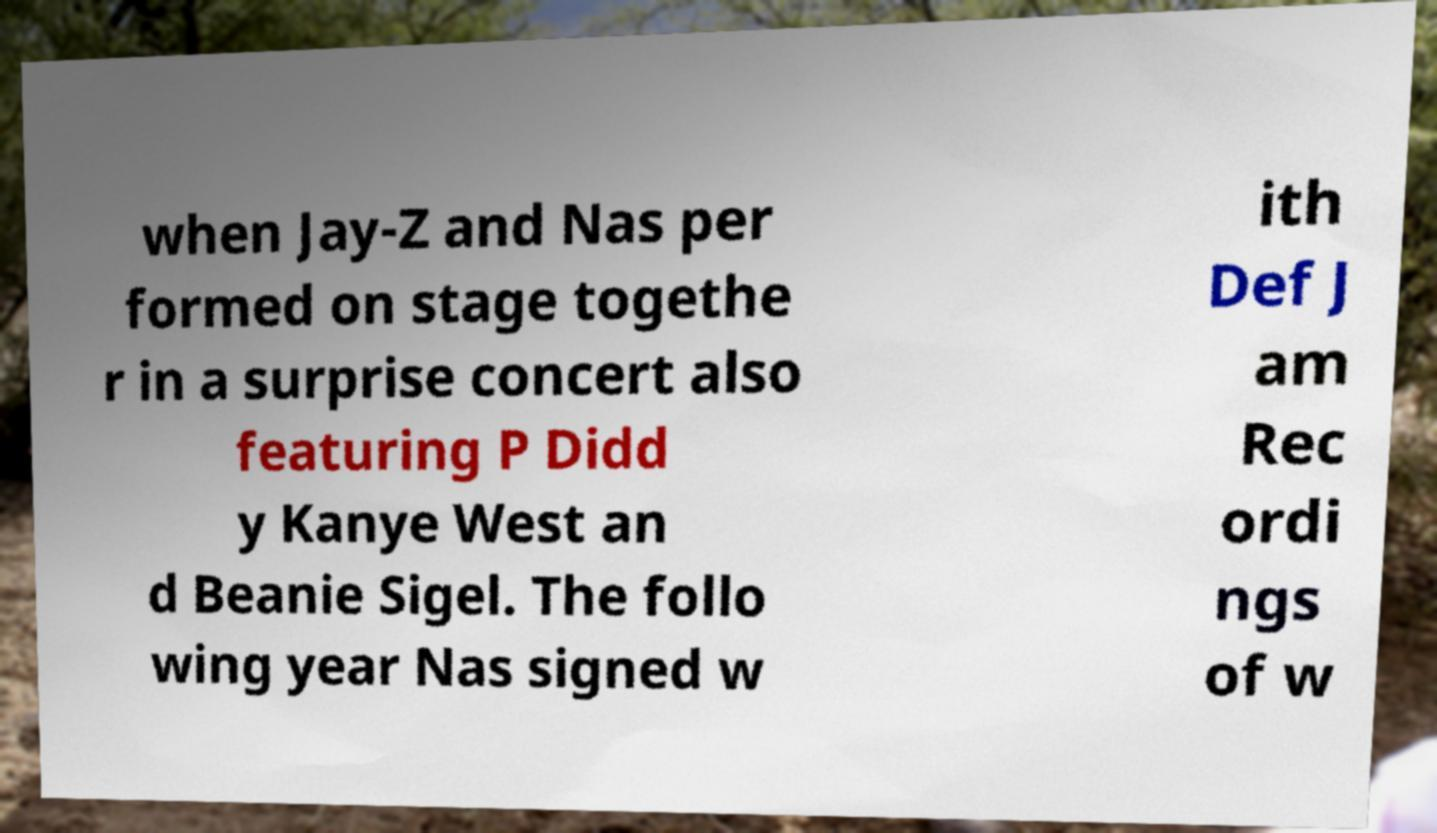Can you read and provide the text displayed in the image?This photo seems to have some interesting text. Can you extract and type it out for me? when Jay-Z and Nas per formed on stage togethe r in a surprise concert also featuring P Didd y Kanye West an d Beanie Sigel. The follo wing year Nas signed w ith Def J am Rec ordi ngs of w 